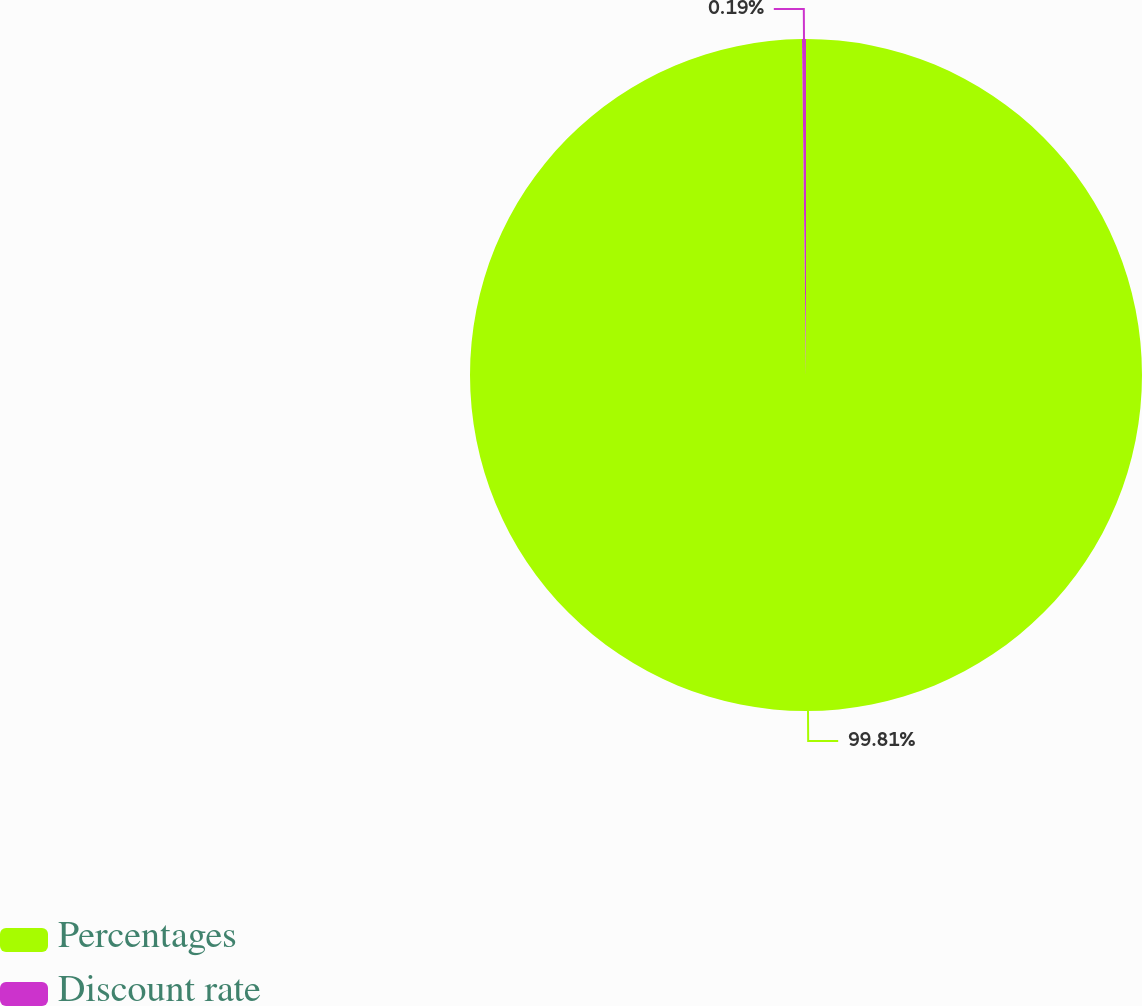Convert chart to OTSL. <chart><loc_0><loc_0><loc_500><loc_500><pie_chart><fcel>Percentages<fcel>Discount rate<nl><fcel>99.81%<fcel>0.19%<nl></chart> 